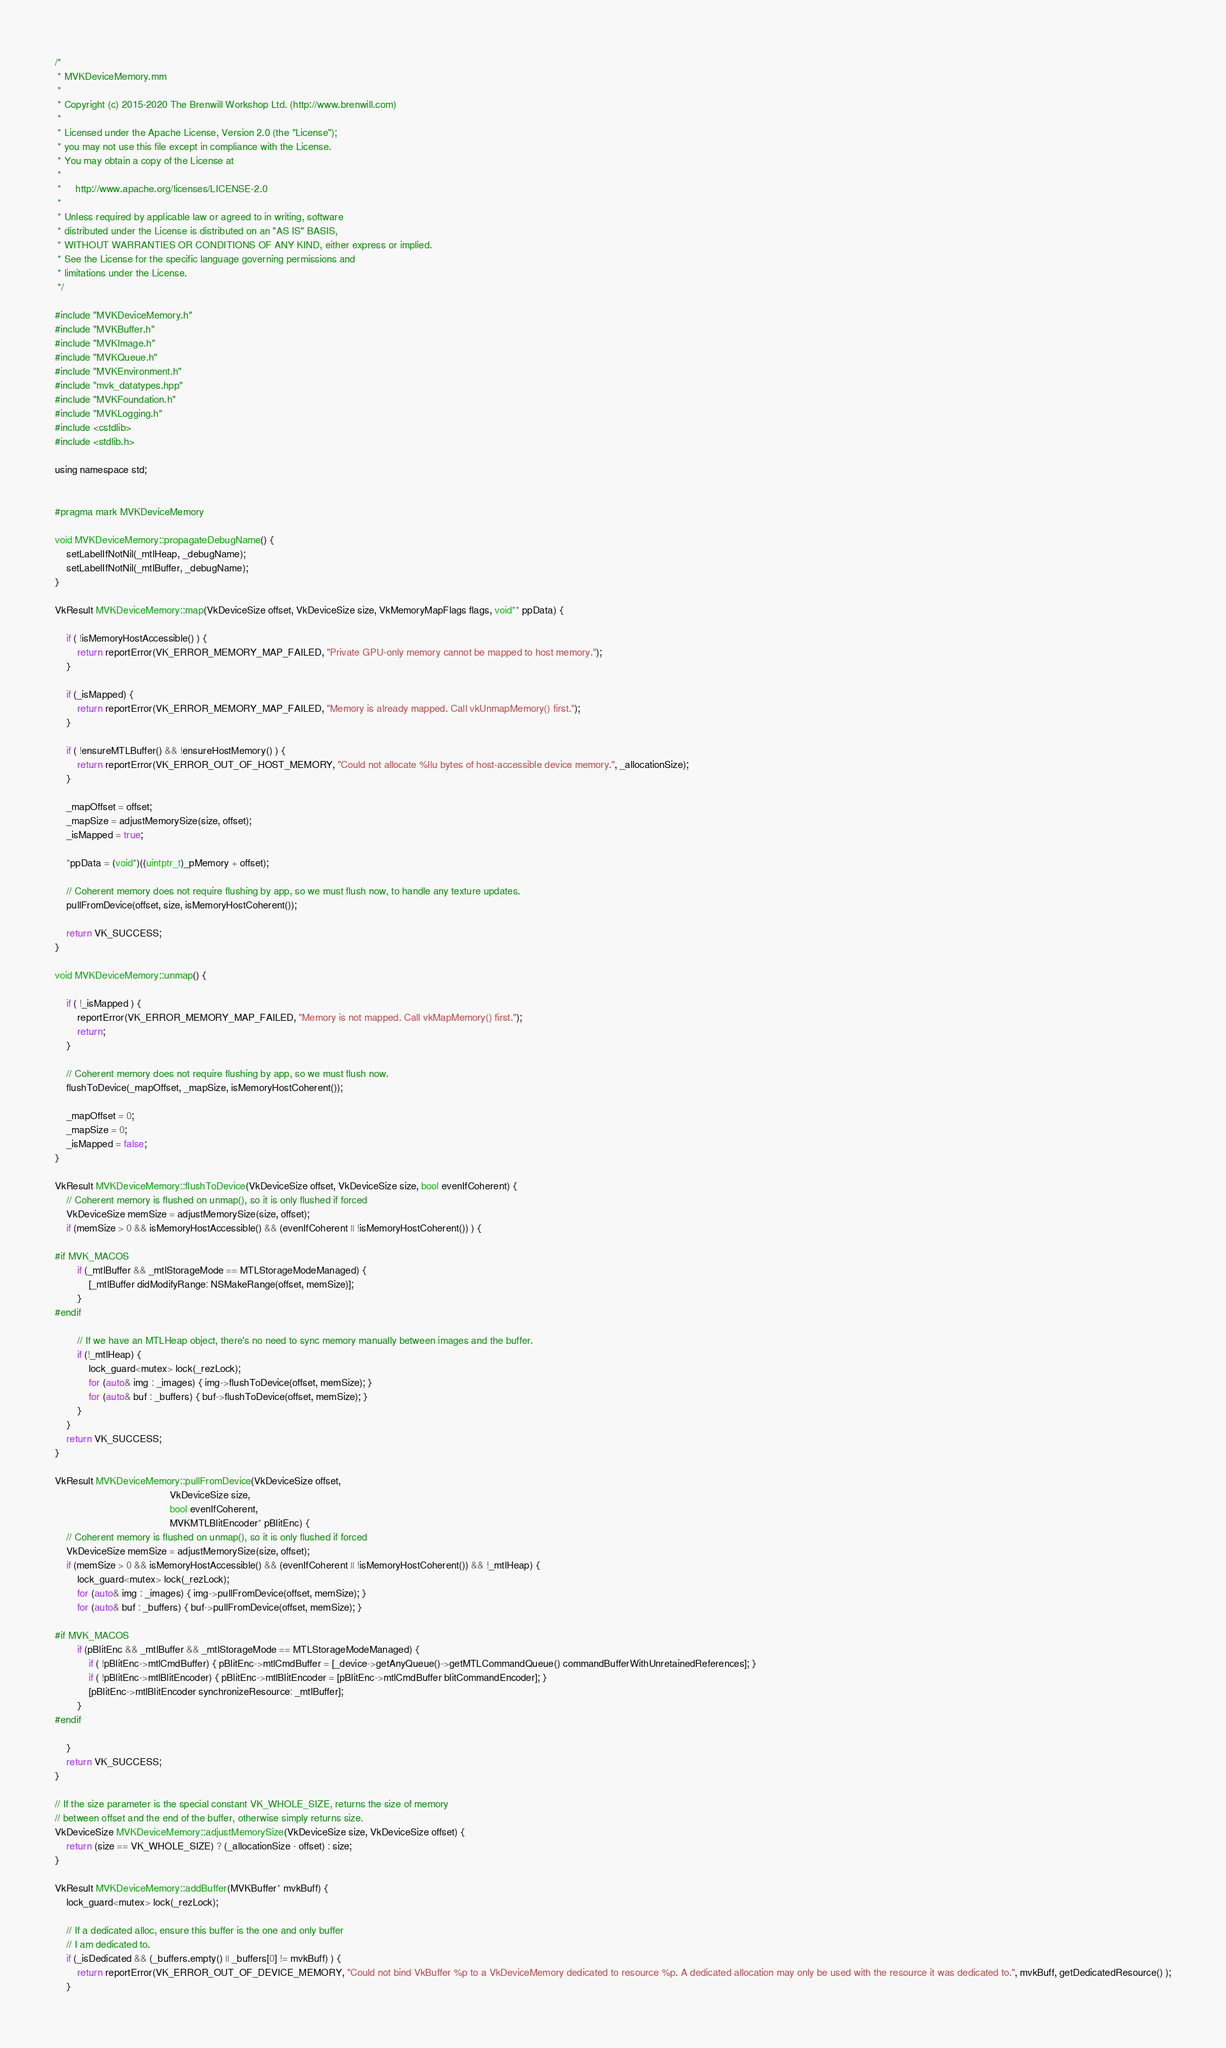<code> <loc_0><loc_0><loc_500><loc_500><_ObjectiveC_>/*
 * MVKDeviceMemory.mm
 *
 * Copyright (c) 2015-2020 The Brenwill Workshop Ltd. (http://www.brenwill.com)
 *
 * Licensed under the Apache License, Version 2.0 (the "License");
 * you may not use this file except in compliance with the License.
 * You may obtain a copy of the License at
 * 
 *     http://www.apache.org/licenses/LICENSE-2.0
 * 
 * Unless required by applicable law or agreed to in writing, software
 * distributed under the License is distributed on an "AS IS" BASIS,
 * WITHOUT WARRANTIES OR CONDITIONS OF ANY KIND, either express or implied.
 * See the License for the specific language governing permissions and
 * limitations under the License.
 */

#include "MVKDeviceMemory.h"
#include "MVKBuffer.h"
#include "MVKImage.h"
#include "MVKQueue.h"
#include "MVKEnvironment.h"
#include "mvk_datatypes.hpp"
#include "MVKFoundation.h"
#include "MVKLogging.h"
#include <cstdlib>
#include <stdlib.h>

using namespace std;


#pragma mark MVKDeviceMemory

void MVKDeviceMemory::propagateDebugName() {
	setLabelIfNotNil(_mtlHeap, _debugName);
	setLabelIfNotNil(_mtlBuffer, _debugName);
}

VkResult MVKDeviceMemory::map(VkDeviceSize offset, VkDeviceSize size, VkMemoryMapFlags flags, void** ppData) {

	if ( !isMemoryHostAccessible() ) {
		return reportError(VK_ERROR_MEMORY_MAP_FAILED, "Private GPU-only memory cannot be mapped to host memory.");
	}

	if (_isMapped) {
		return reportError(VK_ERROR_MEMORY_MAP_FAILED, "Memory is already mapped. Call vkUnmapMemory() first.");
	}

	if ( !ensureMTLBuffer() && !ensureHostMemory() ) {
		return reportError(VK_ERROR_OUT_OF_HOST_MEMORY, "Could not allocate %llu bytes of host-accessible device memory.", _allocationSize);
	}

	_mapOffset = offset;
	_mapSize = adjustMemorySize(size, offset);
	_isMapped = true;

	*ppData = (void*)((uintptr_t)_pMemory + offset);

	// Coherent memory does not require flushing by app, so we must flush now, to handle any texture updates.
	pullFromDevice(offset, size, isMemoryHostCoherent());

	return VK_SUCCESS;
}

void MVKDeviceMemory::unmap() {

	if ( !_isMapped ) {
		reportError(VK_ERROR_MEMORY_MAP_FAILED, "Memory is not mapped. Call vkMapMemory() first.");
		return;
	}

	// Coherent memory does not require flushing by app, so we must flush now.
	flushToDevice(_mapOffset, _mapSize, isMemoryHostCoherent());

	_mapOffset = 0;
	_mapSize = 0;
	_isMapped = false;
}

VkResult MVKDeviceMemory::flushToDevice(VkDeviceSize offset, VkDeviceSize size, bool evenIfCoherent) {
	// Coherent memory is flushed on unmap(), so it is only flushed if forced
	VkDeviceSize memSize = adjustMemorySize(size, offset);
	if (memSize > 0 && isMemoryHostAccessible() && (evenIfCoherent || !isMemoryHostCoherent()) ) {

#if MVK_MACOS
		if (_mtlBuffer && _mtlStorageMode == MTLStorageModeManaged) {
			[_mtlBuffer didModifyRange: NSMakeRange(offset, memSize)];
		}
#endif

		// If we have an MTLHeap object, there's no need to sync memory manually between images and the buffer.
		if (!_mtlHeap) {
			lock_guard<mutex> lock(_rezLock);
			for (auto& img : _images) { img->flushToDevice(offset, memSize); }
			for (auto& buf : _buffers) { buf->flushToDevice(offset, memSize); }
		}
	}
	return VK_SUCCESS;
}

VkResult MVKDeviceMemory::pullFromDevice(VkDeviceSize offset,
										 VkDeviceSize size,
										 bool evenIfCoherent,
										 MVKMTLBlitEncoder* pBlitEnc) {
	// Coherent memory is flushed on unmap(), so it is only flushed if forced
    VkDeviceSize memSize = adjustMemorySize(size, offset);
	if (memSize > 0 && isMemoryHostAccessible() && (evenIfCoherent || !isMemoryHostCoherent()) && !_mtlHeap) {
		lock_guard<mutex> lock(_rezLock);
        for (auto& img : _images) { img->pullFromDevice(offset, memSize); }
        for (auto& buf : _buffers) { buf->pullFromDevice(offset, memSize); }

#if MVK_MACOS
		if (pBlitEnc && _mtlBuffer && _mtlStorageMode == MTLStorageModeManaged) {
			if ( !pBlitEnc->mtlCmdBuffer) { pBlitEnc->mtlCmdBuffer = [_device->getAnyQueue()->getMTLCommandQueue() commandBufferWithUnretainedReferences]; }
			if ( !pBlitEnc->mtlBlitEncoder) { pBlitEnc->mtlBlitEncoder = [pBlitEnc->mtlCmdBuffer blitCommandEncoder]; }
			[pBlitEnc->mtlBlitEncoder synchronizeResource: _mtlBuffer];
		}
#endif

	}
	return VK_SUCCESS;
}

// If the size parameter is the special constant VK_WHOLE_SIZE, returns the size of memory
// between offset and the end of the buffer, otherwise simply returns size.
VkDeviceSize MVKDeviceMemory::adjustMemorySize(VkDeviceSize size, VkDeviceSize offset) {
	return (size == VK_WHOLE_SIZE) ? (_allocationSize - offset) : size;
}

VkResult MVKDeviceMemory::addBuffer(MVKBuffer* mvkBuff) {
	lock_guard<mutex> lock(_rezLock);

	// If a dedicated alloc, ensure this buffer is the one and only buffer
	// I am dedicated to.
	if (_isDedicated && (_buffers.empty() || _buffers[0] != mvkBuff) ) {
		return reportError(VK_ERROR_OUT_OF_DEVICE_MEMORY, "Could not bind VkBuffer %p to a VkDeviceMemory dedicated to resource %p. A dedicated allocation may only be used with the resource it was dedicated to.", mvkBuff, getDedicatedResource() );
	}
</code> 